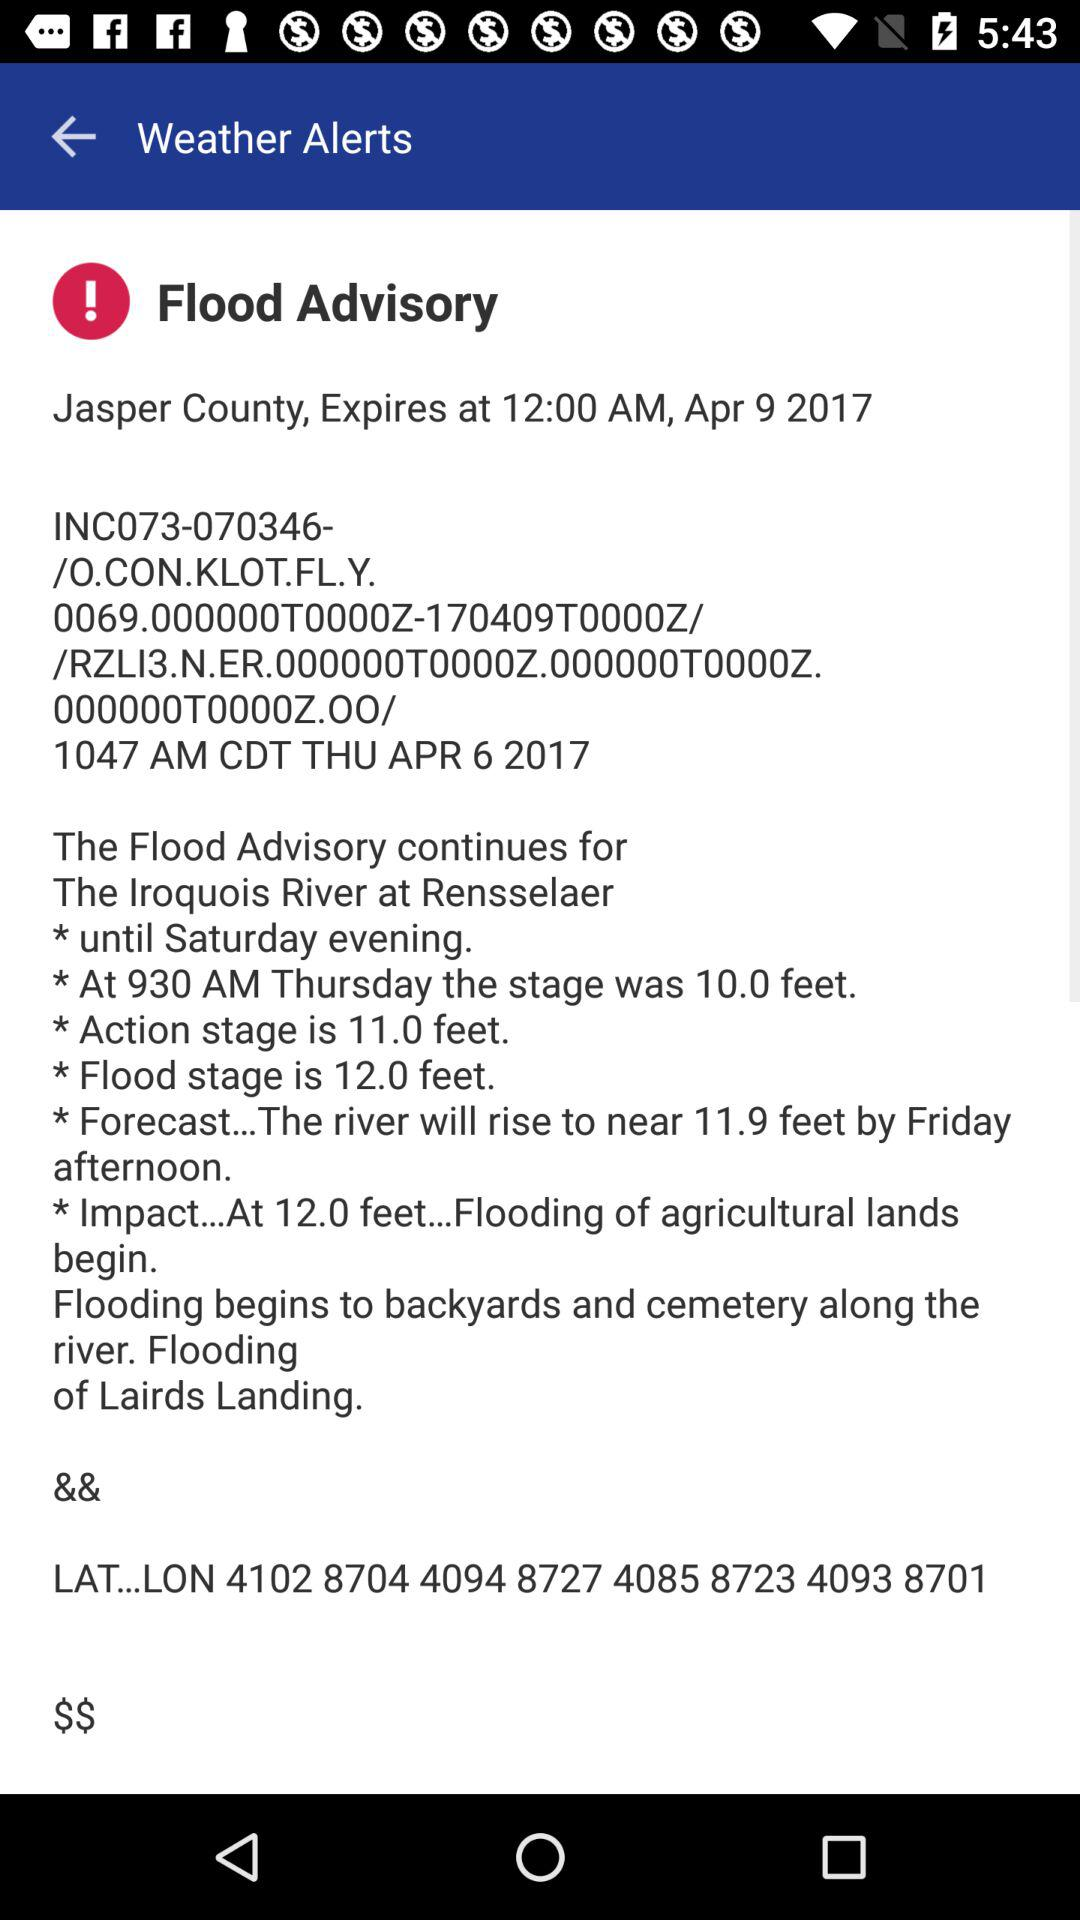By what time will the "Flood Advisory" expire? The "Flood Advisory" will expire on April 9, 2017 at 12:00 AM. 